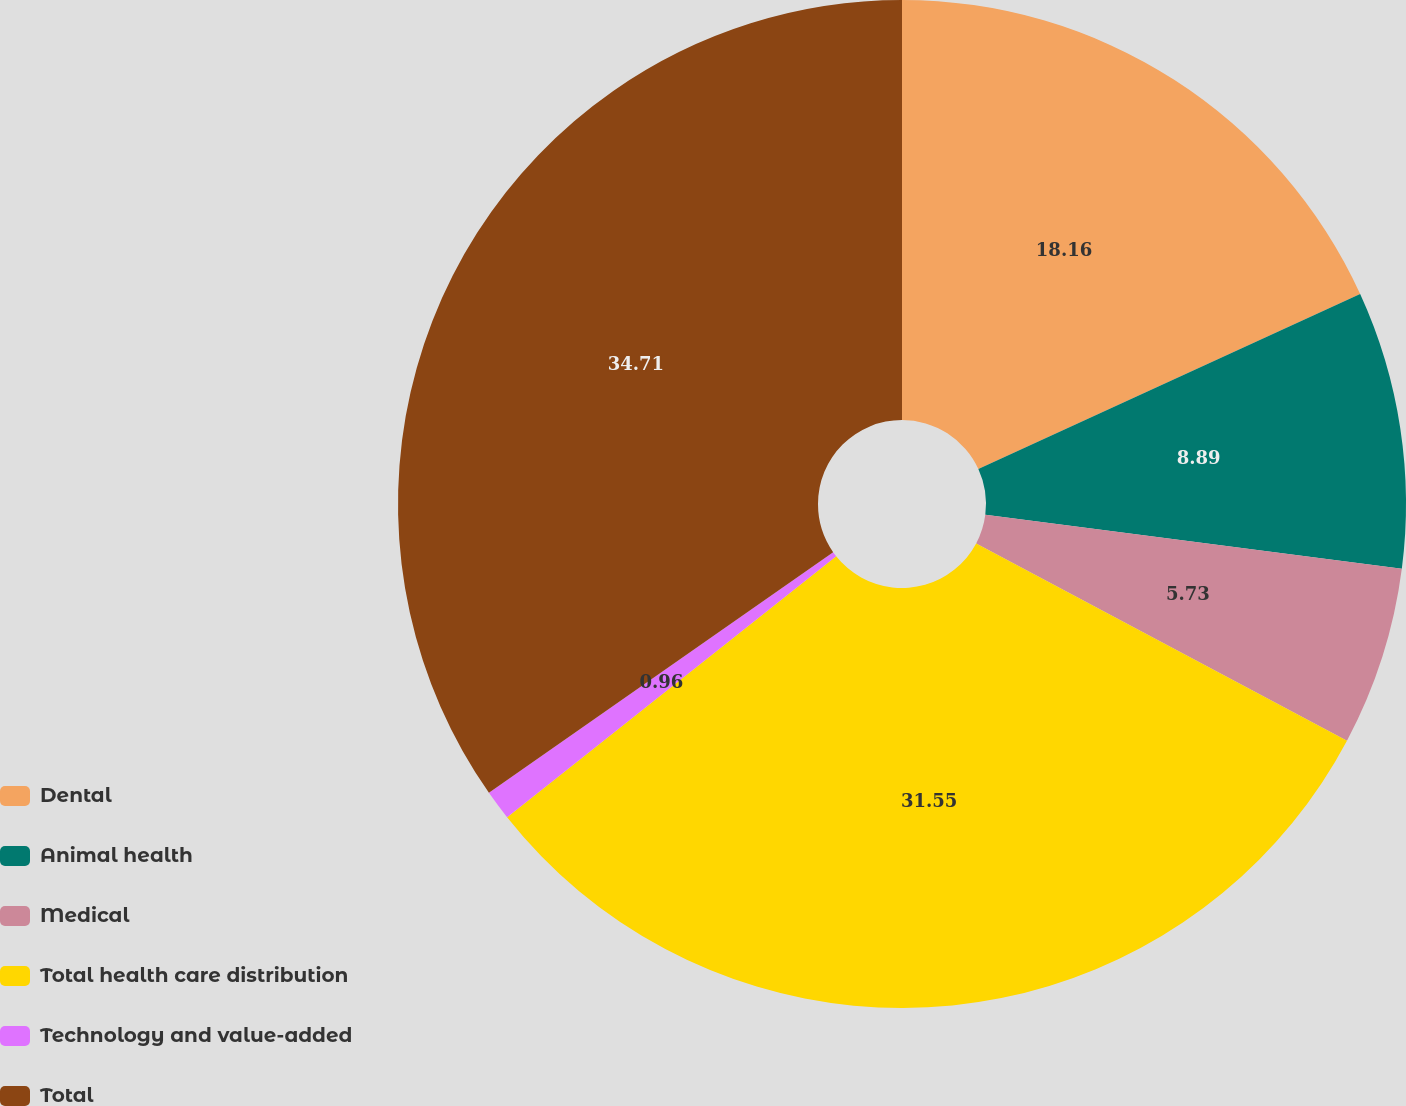Convert chart. <chart><loc_0><loc_0><loc_500><loc_500><pie_chart><fcel>Dental<fcel>Animal health<fcel>Medical<fcel>Total health care distribution<fcel>Technology and value-added<fcel>Total<nl><fcel>18.16%<fcel>8.89%<fcel>5.73%<fcel>31.55%<fcel>0.96%<fcel>34.71%<nl></chart> 